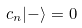<formula> <loc_0><loc_0><loc_500><loc_500>c _ { n } | - \rangle = 0</formula> 